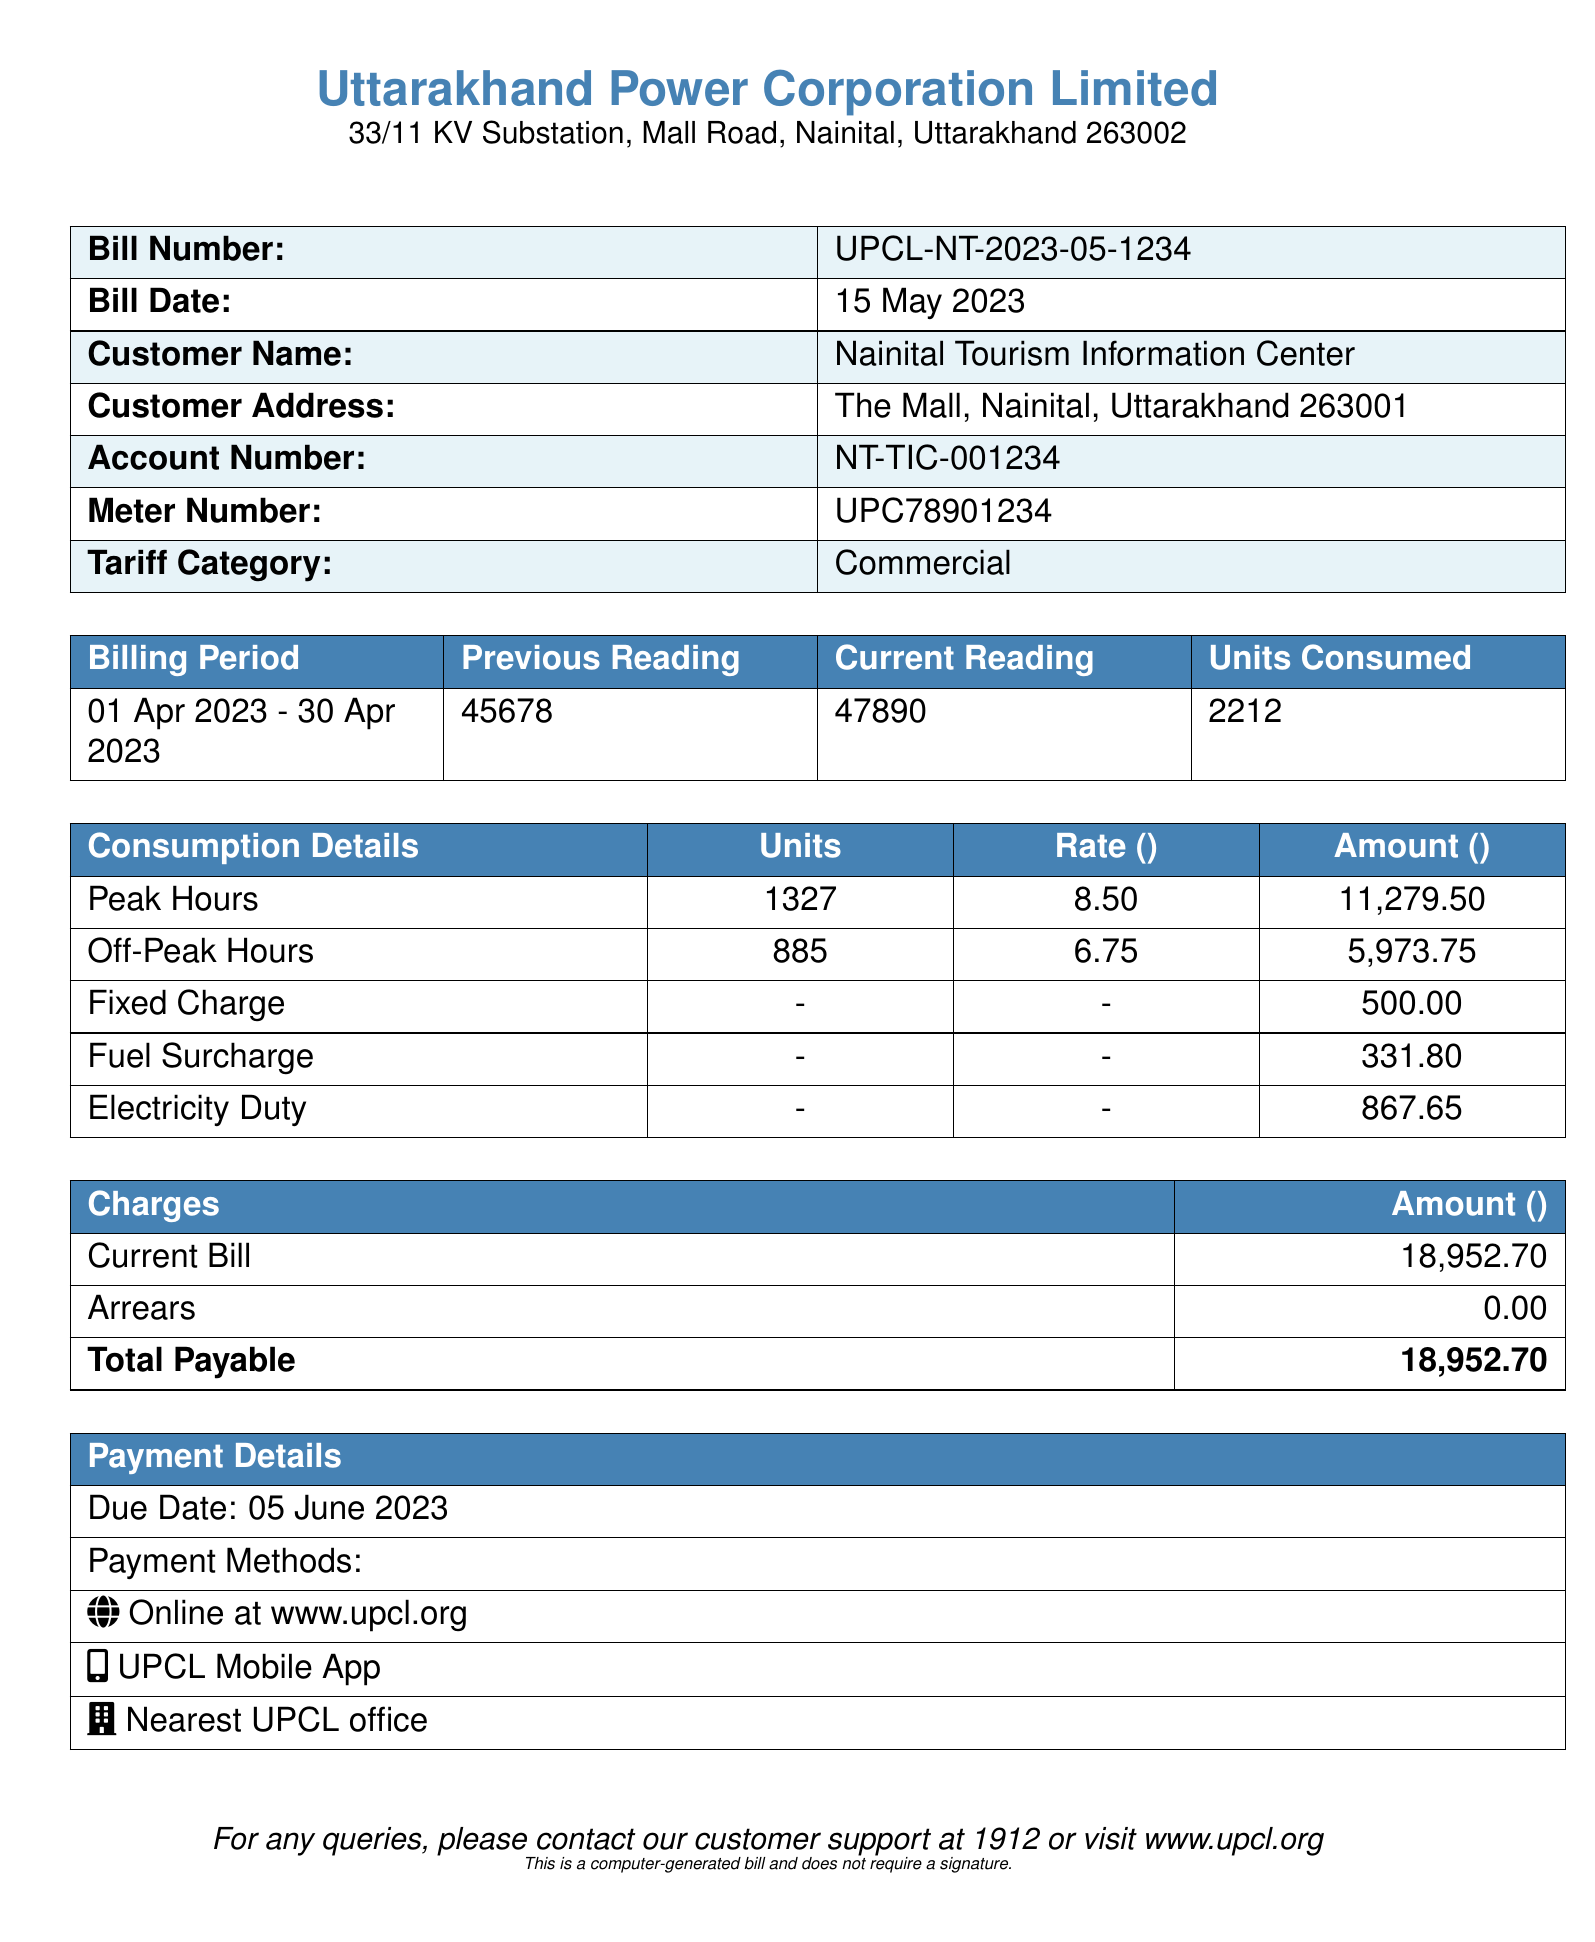What is the bill number? The bill number is specified in the document as UPCL-NT-2023-05-1234.
Answer: UPCL-NT-2023-05-1234 What is the current reading? The current reading shown in the document is 47890.
Answer: 47890 How many units were consumed in total? The total units consumed is detailed in the document as 2212.
Answer: 2212 What is the fixed charge? The fixed charge mentioned in the bill is ₹500.00.
Answer: 500.00 What is the due date for this bill? The due date for payment indicated in the document is 05 June 2023.
Answer: 05 June 2023 What was the peak hours consumption in units? The document states that the peak hours consumption is 1327 units.
Answer: 1327 What is the total payable amount? The total payable amount, according to the summary in the document, is ₹18,952.70.
Answer: 18,952.70 What is the rate per unit charged during off-peak hours? The rate per unit during off-peak hours mentioned is ₹6.75.
Answer: 6.75 What is the fuel surcharge amount? The fuel surcharge amount listed in the bill is ₹331.80.
Answer: 331.80 What is the customer name? The customer name is provided as Nainital Tourism Information Center.
Answer: Nainital Tourism Information Center 